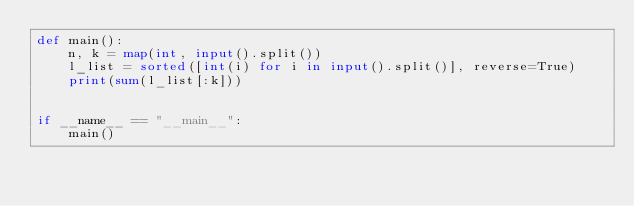Convert code to text. <code><loc_0><loc_0><loc_500><loc_500><_Python_>def main():
    n, k = map(int, input().split())
    l_list = sorted([int(i) for i in input().split()], reverse=True)
    print(sum(l_list[:k]))
    

if __name__ == "__main__":
    main()</code> 